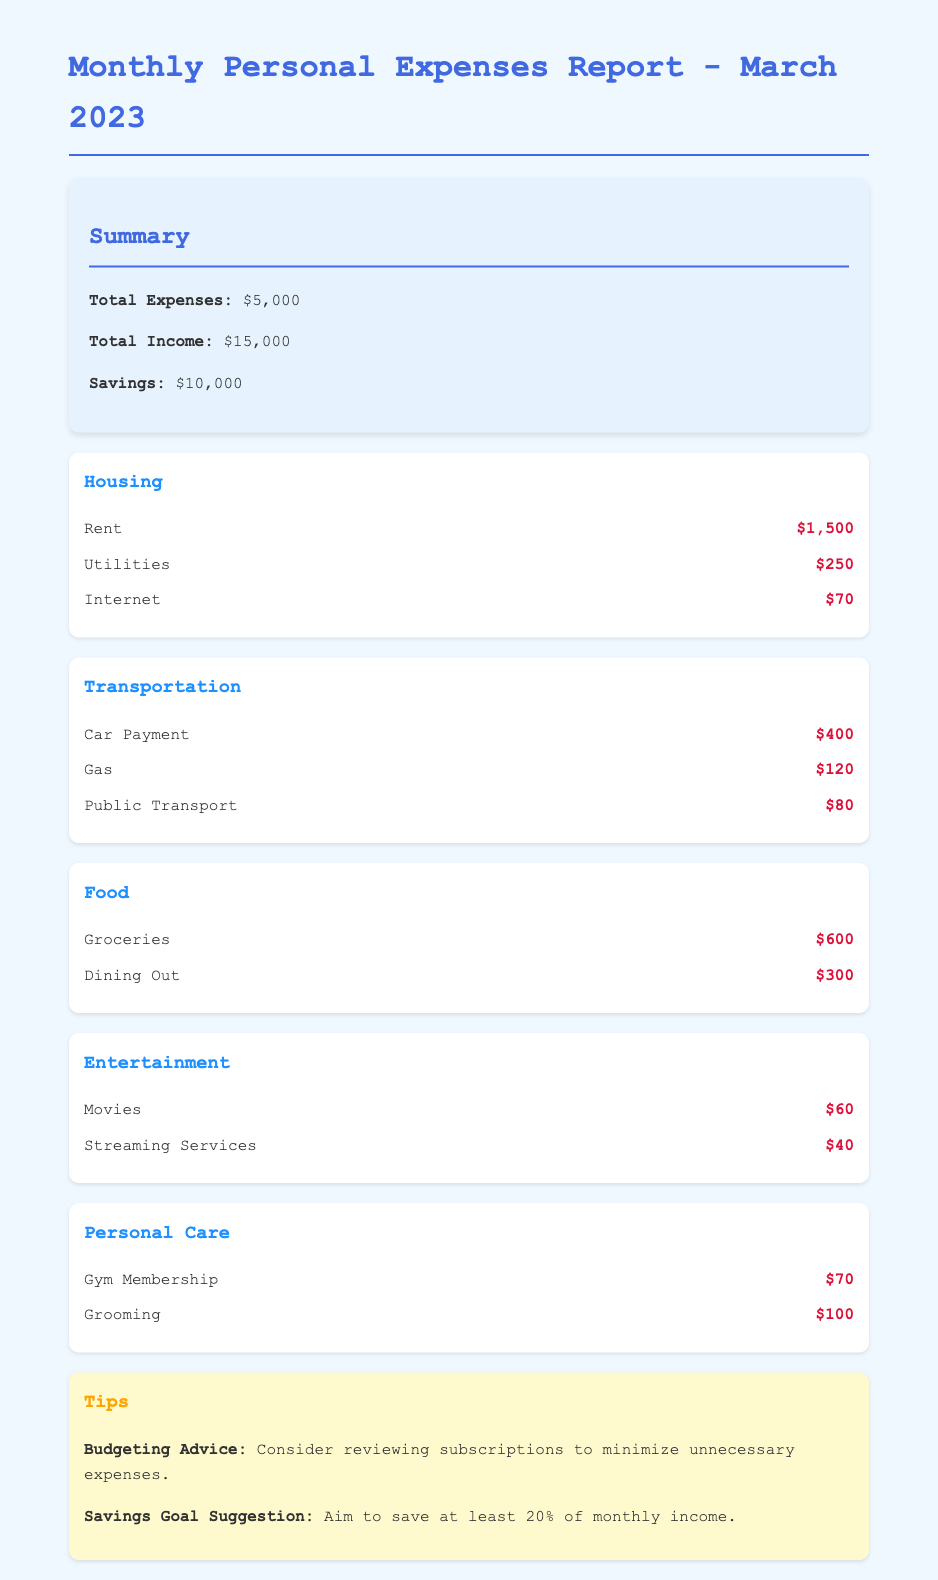What is the total amount spent on housing? The total amount spent on housing includes Rent, Utilities, and Internet, which is $1,500 + $250 + $70 = $1,820.
Answer: $1,820 What was the total income for March 2023? The total income, as stated in the document, is listed directly.
Answer: $15,000 How much was spent on entertainment? The entertainment category includes Movies and Streaming Services, totaling $60 + $40 = $100.
Answer: $100 What percentage of total income is represented by savings? The savings amount is $10,000, which is 66.67% of the total income of $15,000.
Answer: 66.67% What is the expense amount for gas? The expense for gas is listed in the Transportation category of the document.
Answer: $120 Which category has the highest expense? By analyzing the categories, Housing has the highest expense total of $1,820.
Answer: Housing How much was spent on groceries? The amount for groceries is provided in the food category specifically.
Answer: $600 What is one of the budgeting tips mentioned? The document outlines budgeting advice for minimizing subscriptions as a tip.
Answer: Review subscriptions What is the total amount spent on transportation? The total for transportation is calculated as Car Payment + Gas + Public Transport, which equals $400 + $120 + $80 = $600.
Answer: $600 What is the amount spent on dining out? The dining out expense is explicitly stated in the food category.
Answer: $300 